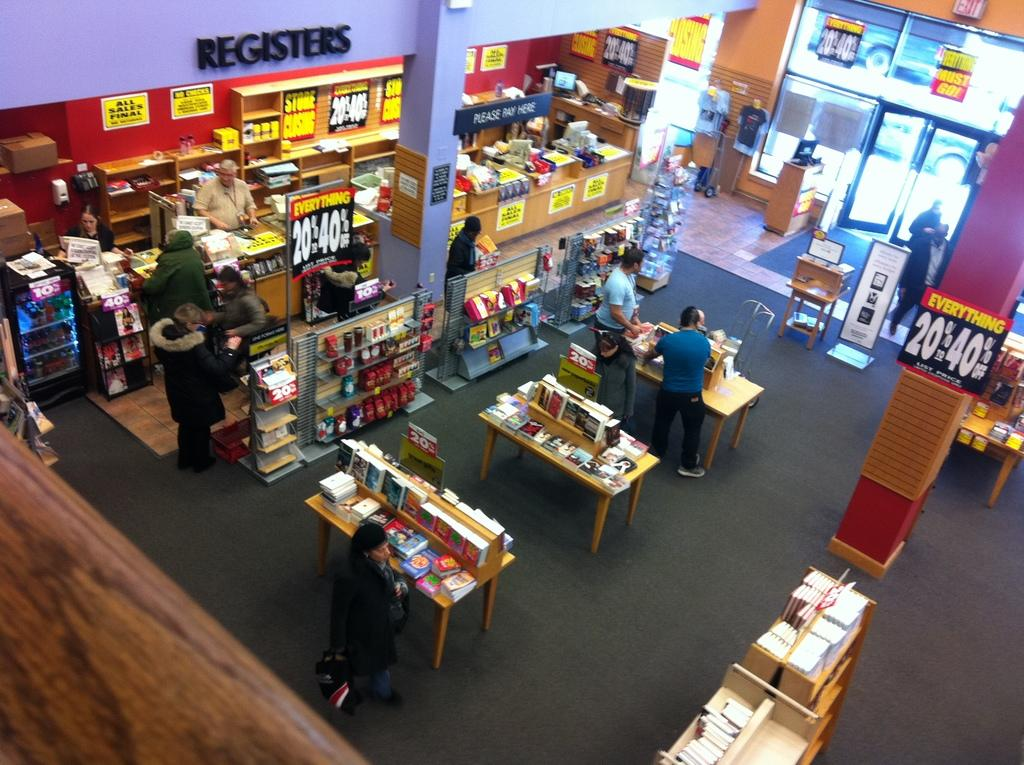What type of structure is visible in the image? There is a wall in the image. What type of furniture is present in the image? There are tables and chairs in the image. What type of objects can be seen on the tables or chairs? There are books in the image. Are there any people present in the image? Yes, there are people standing in the image. What type of poison is being used by the people standing in the image? There is no indication of poison or any poisonous substances in the image. Which direction are the people facing in the image? The image does not provide information about the direction the people are facing. 